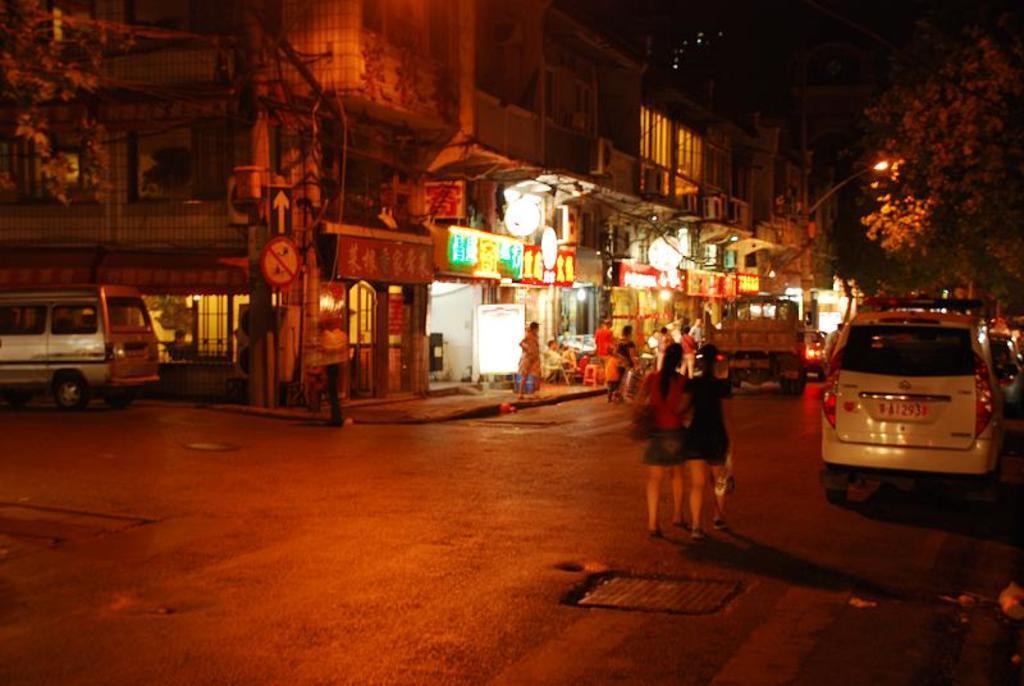In one or two sentences, can you explain what this image depicts? This image is taken outdoors. At the bottom of the image there is a road. In the background there is a building with walls, windows, doors, railings, balconies and pillars. There are many boards with text on them. There is a sign board. A vehicle is parked on the road. A few people are standing on the road and a few are sitting on the chairs. On the right side of the image a few vehicles are moving on the road and two women are walking on the road. There are a few trees and there is a pole with a street light. 